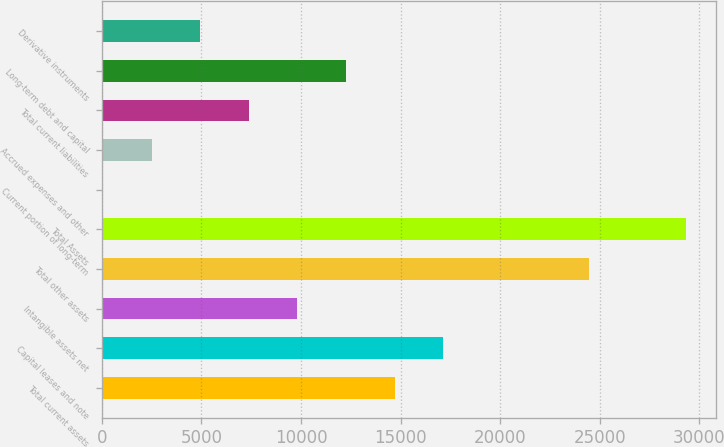Convert chart to OTSL. <chart><loc_0><loc_0><loc_500><loc_500><bar_chart><fcel>Total current assets<fcel>Capital leases and note<fcel>Intangible assets net<fcel>Total other assets<fcel>Total Assets<fcel>Current portion of long-term<fcel>Accrued expenses and other<fcel>Total current liabilities<fcel>Long-term debt and capital<fcel>Derivative instruments<nl><fcel>14705.8<fcel>17147.1<fcel>9823.2<fcel>24471<fcel>29353.6<fcel>58<fcel>2499.3<fcel>7381.9<fcel>12264.5<fcel>4940.6<nl></chart> 